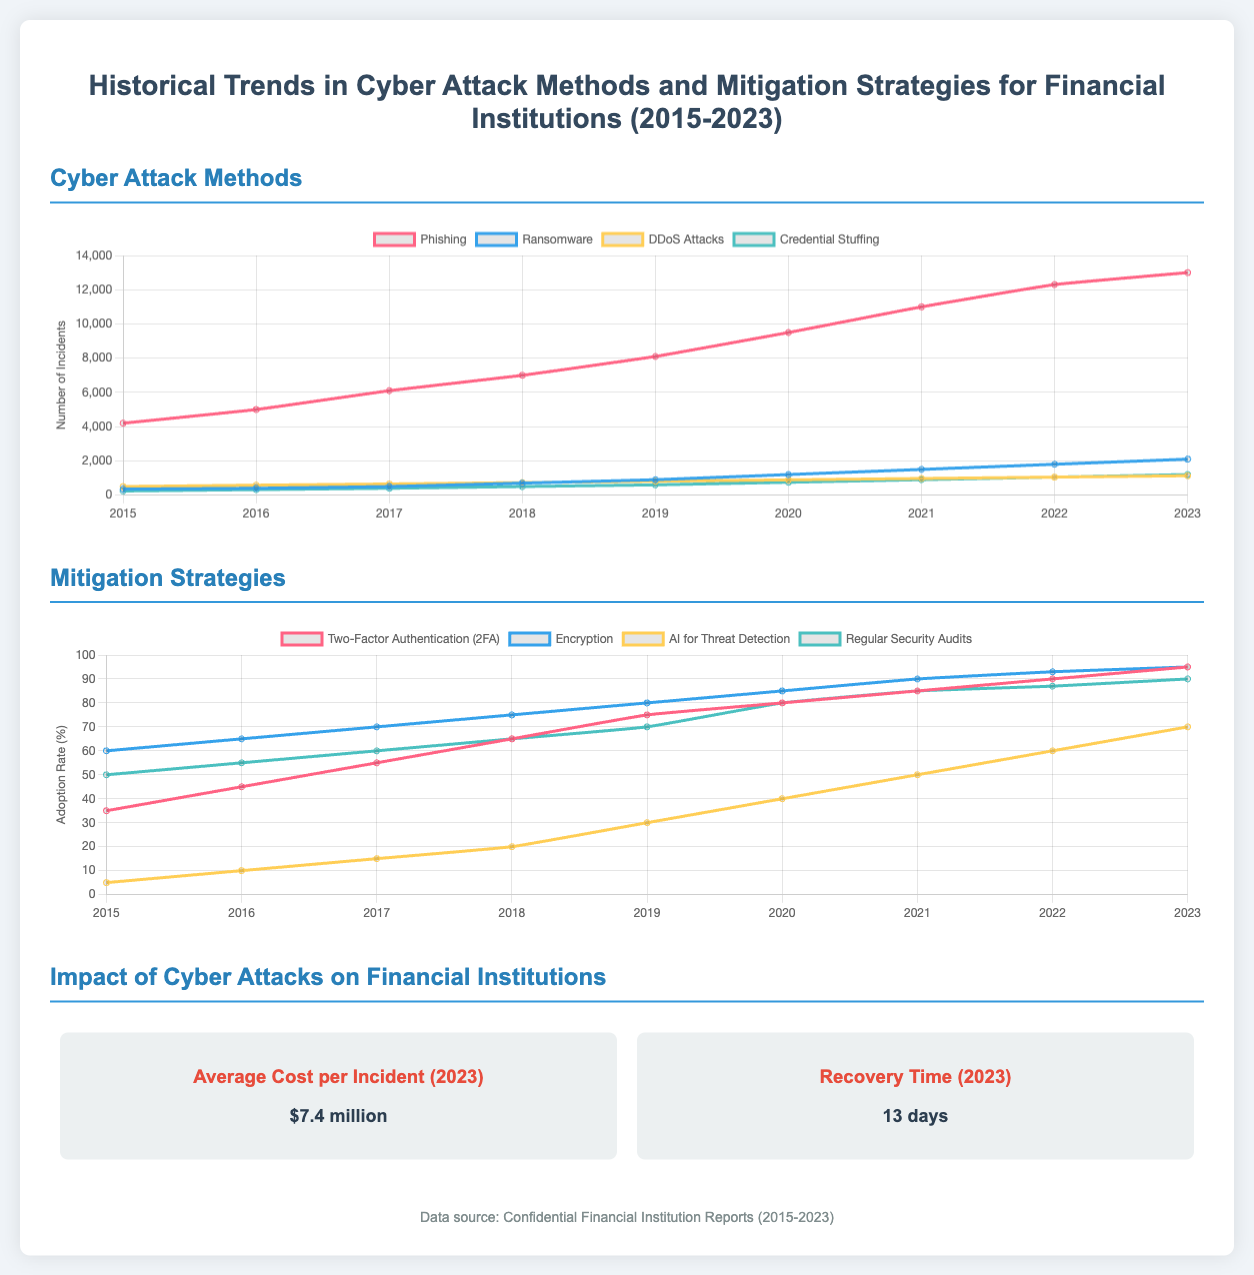What was the average cost per incident in 2023? The average cost per incident in 2023 is listed in the impact section of the document.
Answer: $7.4 million What recovery time is reported for financial institutions in 2023? The recovery time is stated in the impact section of the document.
Answer: 13 days Which cyber attack method showed the highest number of incidents in 2023? The document provides a chart showing the number of incidents for various attack methods, where Phishing has the highest number.
Answer: Phishing What was the adoption rate of Two-Factor Authentication in 2023? The adoption rate for Two-Factor Authentication can be found in the mitigation strategies chart for 2023.
Answer: 95 In which year did the adoption rate for AI for Threat Detection reach 70%? The document details the adoption rates for AI for Threat Detection over the years, where 70% occurs in 2023.
Answer: 2023 What is the trend of Ransomware incidents from 2015 to 2023? Ransomware incidents are listed in a chart which shows an increasing trend from 2015 to 2023.
Answer: Increasing Which mitigation strategy had the lowest adoption rate in 2015? The document lists adoption rates for various strategies, where AI for Threat Detection was the lowest in 2015.
Answer: 5 What percentage of financial institutions adopted Regular Security Audits in 2023? The document provides the adoption rate for Regular Security Audits in 2023.
Answer: 90 Which two cyber attack methods had incident numbers closest to each other in 2023? By comparing the incident numbers from the chart for 2023, Credential Stuffing and Ransomware are closest.
Answer: Credential Stuffing and Ransomware 